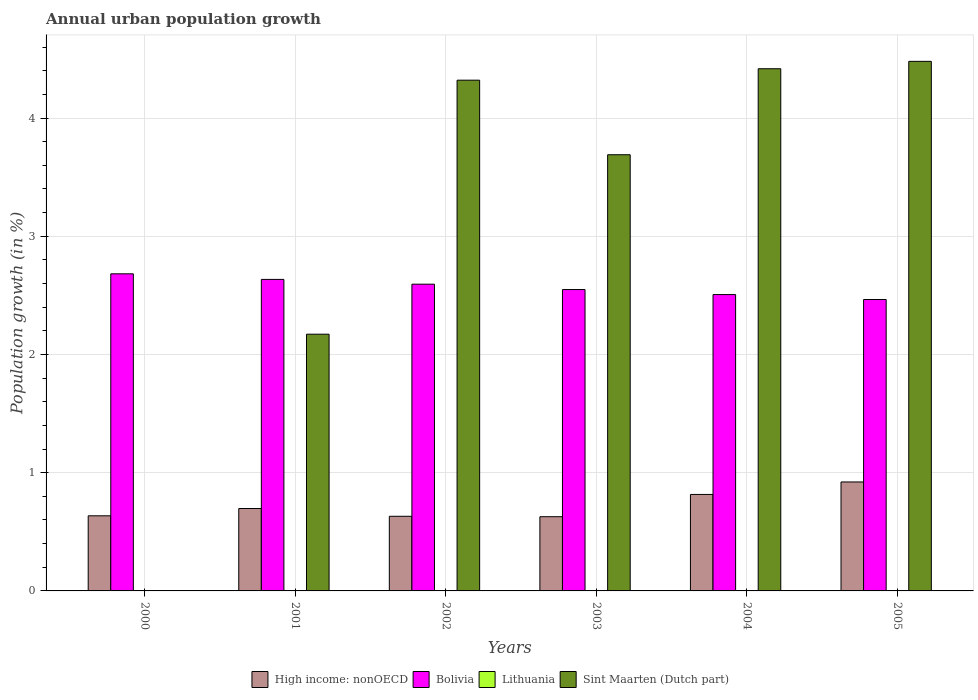How many groups of bars are there?
Provide a succinct answer. 6. How many bars are there on the 4th tick from the left?
Your response must be concise. 3. How many bars are there on the 6th tick from the right?
Your answer should be very brief. 2. In how many cases, is the number of bars for a given year not equal to the number of legend labels?
Offer a very short reply. 6. What is the percentage of urban population growth in Bolivia in 2000?
Make the answer very short. 2.68. Across all years, what is the maximum percentage of urban population growth in Sint Maarten (Dutch part)?
Offer a terse response. 4.48. Across all years, what is the minimum percentage of urban population growth in High income: nonOECD?
Provide a short and direct response. 0.63. What is the total percentage of urban population growth in Bolivia in the graph?
Offer a very short reply. 15.43. What is the difference between the percentage of urban population growth in Sint Maarten (Dutch part) in 2002 and that in 2005?
Make the answer very short. -0.16. What is the difference between the percentage of urban population growth in Sint Maarten (Dutch part) in 2000 and the percentage of urban population growth in High income: nonOECD in 2005?
Offer a very short reply. -0.92. What is the average percentage of urban population growth in Bolivia per year?
Provide a succinct answer. 2.57. In the year 2001, what is the difference between the percentage of urban population growth in High income: nonOECD and percentage of urban population growth in Sint Maarten (Dutch part)?
Provide a short and direct response. -1.47. What is the ratio of the percentage of urban population growth in Bolivia in 2003 to that in 2005?
Offer a very short reply. 1.03. Is the percentage of urban population growth in Bolivia in 2004 less than that in 2005?
Ensure brevity in your answer.  No. Is the difference between the percentage of urban population growth in High income: nonOECD in 2001 and 2005 greater than the difference between the percentage of urban population growth in Sint Maarten (Dutch part) in 2001 and 2005?
Offer a terse response. Yes. What is the difference between the highest and the second highest percentage of urban population growth in High income: nonOECD?
Offer a very short reply. 0.11. What is the difference between the highest and the lowest percentage of urban population growth in Sint Maarten (Dutch part)?
Offer a terse response. 4.48. In how many years, is the percentage of urban population growth in Bolivia greater than the average percentage of urban population growth in Bolivia taken over all years?
Provide a succinct answer. 3. Is the sum of the percentage of urban population growth in Sint Maarten (Dutch part) in 2003 and 2005 greater than the maximum percentage of urban population growth in Lithuania across all years?
Offer a terse response. Yes. Is it the case that in every year, the sum of the percentage of urban population growth in Bolivia and percentage of urban population growth in Lithuania is greater than the sum of percentage of urban population growth in Sint Maarten (Dutch part) and percentage of urban population growth in High income: nonOECD?
Provide a short and direct response. No. How many bars are there?
Make the answer very short. 17. Are all the bars in the graph horizontal?
Give a very brief answer. No. How many years are there in the graph?
Offer a terse response. 6. What is the difference between two consecutive major ticks on the Y-axis?
Make the answer very short. 1. Does the graph contain any zero values?
Make the answer very short. Yes. Where does the legend appear in the graph?
Your answer should be very brief. Bottom center. How are the legend labels stacked?
Provide a succinct answer. Horizontal. What is the title of the graph?
Provide a short and direct response. Annual urban population growth. What is the label or title of the X-axis?
Your answer should be compact. Years. What is the label or title of the Y-axis?
Your response must be concise. Population growth (in %). What is the Population growth (in %) of High income: nonOECD in 2000?
Your response must be concise. 0.64. What is the Population growth (in %) in Bolivia in 2000?
Your answer should be very brief. 2.68. What is the Population growth (in %) in Lithuania in 2000?
Your answer should be compact. 0. What is the Population growth (in %) of Sint Maarten (Dutch part) in 2000?
Your answer should be very brief. 0. What is the Population growth (in %) of High income: nonOECD in 2001?
Your answer should be very brief. 0.7. What is the Population growth (in %) in Bolivia in 2001?
Your response must be concise. 2.64. What is the Population growth (in %) of Lithuania in 2001?
Keep it short and to the point. 0. What is the Population growth (in %) of Sint Maarten (Dutch part) in 2001?
Provide a short and direct response. 2.17. What is the Population growth (in %) in High income: nonOECD in 2002?
Your answer should be very brief. 0.63. What is the Population growth (in %) of Bolivia in 2002?
Ensure brevity in your answer.  2.59. What is the Population growth (in %) of Lithuania in 2002?
Provide a short and direct response. 0. What is the Population growth (in %) of Sint Maarten (Dutch part) in 2002?
Make the answer very short. 4.32. What is the Population growth (in %) in High income: nonOECD in 2003?
Your answer should be very brief. 0.63. What is the Population growth (in %) in Bolivia in 2003?
Provide a short and direct response. 2.55. What is the Population growth (in %) of Lithuania in 2003?
Ensure brevity in your answer.  0. What is the Population growth (in %) in Sint Maarten (Dutch part) in 2003?
Your answer should be very brief. 3.69. What is the Population growth (in %) of High income: nonOECD in 2004?
Your response must be concise. 0.82. What is the Population growth (in %) in Bolivia in 2004?
Keep it short and to the point. 2.51. What is the Population growth (in %) in Sint Maarten (Dutch part) in 2004?
Provide a succinct answer. 4.42. What is the Population growth (in %) in High income: nonOECD in 2005?
Your response must be concise. 0.92. What is the Population growth (in %) in Bolivia in 2005?
Give a very brief answer. 2.47. What is the Population growth (in %) in Sint Maarten (Dutch part) in 2005?
Ensure brevity in your answer.  4.48. Across all years, what is the maximum Population growth (in %) of High income: nonOECD?
Keep it short and to the point. 0.92. Across all years, what is the maximum Population growth (in %) in Bolivia?
Provide a succinct answer. 2.68. Across all years, what is the maximum Population growth (in %) of Sint Maarten (Dutch part)?
Provide a short and direct response. 4.48. Across all years, what is the minimum Population growth (in %) in High income: nonOECD?
Offer a very short reply. 0.63. Across all years, what is the minimum Population growth (in %) in Bolivia?
Your response must be concise. 2.47. What is the total Population growth (in %) in High income: nonOECD in the graph?
Provide a succinct answer. 4.33. What is the total Population growth (in %) of Bolivia in the graph?
Keep it short and to the point. 15.43. What is the total Population growth (in %) of Sint Maarten (Dutch part) in the graph?
Offer a terse response. 19.08. What is the difference between the Population growth (in %) in High income: nonOECD in 2000 and that in 2001?
Your answer should be compact. -0.06. What is the difference between the Population growth (in %) of Bolivia in 2000 and that in 2001?
Provide a succinct answer. 0.05. What is the difference between the Population growth (in %) of High income: nonOECD in 2000 and that in 2002?
Make the answer very short. 0. What is the difference between the Population growth (in %) of Bolivia in 2000 and that in 2002?
Your answer should be very brief. 0.09. What is the difference between the Population growth (in %) of High income: nonOECD in 2000 and that in 2003?
Ensure brevity in your answer.  0.01. What is the difference between the Population growth (in %) in Bolivia in 2000 and that in 2003?
Keep it short and to the point. 0.13. What is the difference between the Population growth (in %) of High income: nonOECD in 2000 and that in 2004?
Make the answer very short. -0.18. What is the difference between the Population growth (in %) in Bolivia in 2000 and that in 2004?
Provide a succinct answer. 0.18. What is the difference between the Population growth (in %) of High income: nonOECD in 2000 and that in 2005?
Make the answer very short. -0.29. What is the difference between the Population growth (in %) of Bolivia in 2000 and that in 2005?
Provide a succinct answer. 0.22. What is the difference between the Population growth (in %) in High income: nonOECD in 2001 and that in 2002?
Offer a very short reply. 0.07. What is the difference between the Population growth (in %) in Bolivia in 2001 and that in 2002?
Give a very brief answer. 0.04. What is the difference between the Population growth (in %) in Sint Maarten (Dutch part) in 2001 and that in 2002?
Offer a very short reply. -2.15. What is the difference between the Population growth (in %) in High income: nonOECD in 2001 and that in 2003?
Provide a succinct answer. 0.07. What is the difference between the Population growth (in %) of Bolivia in 2001 and that in 2003?
Provide a short and direct response. 0.09. What is the difference between the Population growth (in %) of Sint Maarten (Dutch part) in 2001 and that in 2003?
Keep it short and to the point. -1.52. What is the difference between the Population growth (in %) in High income: nonOECD in 2001 and that in 2004?
Provide a short and direct response. -0.12. What is the difference between the Population growth (in %) in Bolivia in 2001 and that in 2004?
Keep it short and to the point. 0.13. What is the difference between the Population growth (in %) of Sint Maarten (Dutch part) in 2001 and that in 2004?
Offer a terse response. -2.25. What is the difference between the Population growth (in %) in High income: nonOECD in 2001 and that in 2005?
Make the answer very short. -0.22. What is the difference between the Population growth (in %) in Bolivia in 2001 and that in 2005?
Your answer should be compact. 0.17. What is the difference between the Population growth (in %) in Sint Maarten (Dutch part) in 2001 and that in 2005?
Offer a terse response. -2.31. What is the difference between the Population growth (in %) in High income: nonOECD in 2002 and that in 2003?
Keep it short and to the point. 0. What is the difference between the Population growth (in %) of Bolivia in 2002 and that in 2003?
Give a very brief answer. 0.05. What is the difference between the Population growth (in %) of Sint Maarten (Dutch part) in 2002 and that in 2003?
Ensure brevity in your answer.  0.63. What is the difference between the Population growth (in %) of High income: nonOECD in 2002 and that in 2004?
Your answer should be very brief. -0.18. What is the difference between the Population growth (in %) of Bolivia in 2002 and that in 2004?
Provide a short and direct response. 0.09. What is the difference between the Population growth (in %) in Sint Maarten (Dutch part) in 2002 and that in 2004?
Provide a short and direct response. -0.1. What is the difference between the Population growth (in %) in High income: nonOECD in 2002 and that in 2005?
Provide a short and direct response. -0.29. What is the difference between the Population growth (in %) of Bolivia in 2002 and that in 2005?
Provide a succinct answer. 0.13. What is the difference between the Population growth (in %) in Sint Maarten (Dutch part) in 2002 and that in 2005?
Your response must be concise. -0.16. What is the difference between the Population growth (in %) in High income: nonOECD in 2003 and that in 2004?
Your answer should be very brief. -0.19. What is the difference between the Population growth (in %) in Bolivia in 2003 and that in 2004?
Your response must be concise. 0.04. What is the difference between the Population growth (in %) in Sint Maarten (Dutch part) in 2003 and that in 2004?
Provide a succinct answer. -0.73. What is the difference between the Population growth (in %) in High income: nonOECD in 2003 and that in 2005?
Ensure brevity in your answer.  -0.29. What is the difference between the Population growth (in %) of Bolivia in 2003 and that in 2005?
Make the answer very short. 0.08. What is the difference between the Population growth (in %) in Sint Maarten (Dutch part) in 2003 and that in 2005?
Offer a very short reply. -0.79. What is the difference between the Population growth (in %) in High income: nonOECD in 2004 and that in 2005?
Your answer should be compact. -0.11. What is the difference between the Population growth (in %) in Bolivia in 2004 and that in 2005?
Your response must be concise. 0.04. What is the difference between the Population growth (in %) in Sint Maarten (Dutch part) in 2004 and that in 2005?
Your answer should be compact. -0.06. What is the difference between the Population growth (in %) of High income: nonOECD in 2000 and the Population growth (in %) of Bolivia in 2001?
Provide a succinct answer. -2. What is the difference between the Population growth (in %) in High income: nonOECD in 2000 and the Population growth (in %) in Sint Maarten (Dutch part) in 2001?
Give a very brief answer. -1.54. What is the difference between the Population growth (in %) in Bolivia in 2000 and the Population growth (in %) in Sint Maarten (Dutch part) in 2001?
Your answer should be compact. 0.51. What is the difference between the Population growth (in %) in High income: nonOECD in 2000 and the Population growth (in %) in Bolivia in 2002?
Keep it short and to the point. -1.96. What is the difference between the Population growth (in %) of High income: nonOECD in 2000 and the Population growth (in %) of Sint Maarten (Dutch part) in 2002?
Your response must be concise. -3.68. What is the difference between the Population growth (in %) of Bolivia in 2000 and the Population growth (in %) of Sint Maarten (Dutch part) in 2002?
Give a very brief answer. -1.64. What is the difference between the Population growth (in %) of High income: nonOECD in 2000 and the Population growth (in %) of Bolivia in 2003?
Your answer should be compact. -1.91. What is the difference between the Population growth (in %) in High income: nonOECD in 2000 and the Population growth (in %) in Sint Maarten (Dutch part) in 2003?
Keep it short and to the point. -3.05. What is the difference between the Population growth (in %) of Bolivia in 2000 and the Population growth (in %) of Sint Maarten (Dutch part) in 2003?
Provide a succinct answer. -1.01. What is the difference between the Population growth (in %) in High income: nonOECD in 2000 and the Population growth (in %) in Bolivia in 2004?
Give a very brief answer. -1.87. What is the difference between the Population growth (in %) of High income: nonOECD in 2000 and the Population growth (in %) of Sint Maarten (Dutch part) in 2004?
Ensure brevity in your answer.  -3.78. What is the difference between the Population growth (in %) in Bolivia in 2000 and the Population growth (in %) in Sint Maarten (Dutch part) in 2004?
Your response must be concise. -1.73. What is the difference between the Population growth (in %) in High income: nonOECD in 2000 and the Population growth (in %) in Bolivia in 2005?
Provide a succinct answer. -1.83. What is the difference between the Population growth (in %) in High income: nonOECD in 2000 and the Population growth (in %) in Sint Maarten (Dutch part) in 2005?
Ensure brevity in your answer.  -3.84. What is the difference between the Population growth (in %) in Bolivia in 2000 and the Population growth (in %) in Sint Maarten (Dutch part) in 2005?
Your answer should be compact. -1.8. What is the difference between the Population growth (in %) of High income: nonOECD in 2001 and the Population growth (in %) of Bolivia in 2002?
Offer a terse response. -1.9. What is the difference between the Population growth (in %) in High income: nonOECD in 2001 and the Population growth (in %) in Sint Maarten (Dutch part) in 2002?
Keep it short and to the point. -3.62. What is the difference between the Population growth (in %) in Bolivia in 2001 and the Population growth (in %) in Sint Maarten (Dutch part) in 2002?
Provide a short and direct response. -1.69. What is the difference between the Population growth (in %) of High income: nonOECD in 2001 and the Population growth (in %) of Bolivia in 2003?
Provide a succinct answer. -1.85. What is the difference between the Population growth (in %) in High income: nonOECD in 2001 and the Population growth (in %) in Sint Maarten (Dutch part) in 2003?
Your answer should be very brief. -2.99. What is the difference between the Population growth (in %) of Bolivia in 2001 and the Population growth (in %) of Sint Maarten (Dutch part) in 2003?
Offer a very short reply. -1.05. What is the difference between the Population growth (in %) in High income: nonOECD in 2001 and the Population growth (in %) in Bolivia in 2004?
Keep it short and to the point. -1.81. What is the difference between the Population growth (in %) of High income: nonOECD in 2001 and the Population growth (in %) of Sint Maarten (Dutch part) in 2004?
Provide a succinct answer. -3.72. What is the difference between the Population growth (in %) in Bolivia in 2001 and the Population growth (in %) in Sint Maarten (Dutch part) in 2004?
Offer a terse response. -1.78. What is the difference between the Population growth (in %) in High income: nonOECD in 2001 and the Population growth (in %) in Bolivia in 2005?
Your answer should be compact. -1.77. What is the difference between the Population growth (in %) of High income: nonOECD in 2001 and the Population growth (in %) of Sint Maarten (Dutch part) in 2005?
Offer a terse response. -3.78. What is the difference between the Population growth (in %) of Bolivia in 2001 and the Population growth (in %) of Sint Maarten (Dutch part) in 2005?
Keep it short and to the point. -1.84. What is the difference between the Population growth (in %) in High income: nonOECD in 2002 and the Population growth (in %) in Bolivia in 2003?
Your response must be concise. -1.92. What is the difference between the Population growth (in %) of High income: nonOECD in 2002 and the Population growth (in %) of Sint Maarten (Dutch part) in 2003?
Ensure brevity in your answer.  -3.06. What is the difference between the Population growth (in %) in Bolivia in 2002 and the Population growth (in %) in Sint Maarten (Dutch part) in 2003?
Provide a succinct answer. -1.09. What is the difference between the Population growth (in %) of High income: nonOECD in 2002 and the Population growth (in %) of Bolivia in 2004?
Your answer should be compact. -1.88. What is the difference between the Population growth (in %) in High income: nonOECD in 2002 and the Population growth (in %) in Sint Maarten (Dutch part) in 2004?
Offer a very short reply. -3.79. What is the difference between the Population growth (in %) in Bolivia in 2002 and the Population growth (in %) in Sint Maarten (Dutch part) in 2004?
Provide a short and direct response. -1.82. What is the difference between the Population growth (in %) of High income: nonOECD in 2002 and the Population growth (in %) of Bolivia in 2005?
Make the answer very short. -1.83. What is the difference between the Population growth (in %) of High income: nonOECD in 2002 and the Population growth (in %) of Sint Maarten (Dutch part) in 2005?
Provide a succinct answer. -3.85. What is the difference between the Population growth (in %) in Bolivia in 2002 and the Population growth (in %) in Sint Maarten (Dutch part) in 2005?
Your answer should be compact. -1.88. What is the difference between the Population growth (in %) of High income: nonOECD in 2003 and the Population growth (in %) of Bolivia in 2004?
Keep it short and to the point. -1.88. What is the difference between the Population growth (in %) in High income: nonOECD in 2003 and the Population growth (in %) in Sint Maarten (Dutch part) in 2004?
Give a very brief answer. -3.79. What is the difference between the Population growth (in %) in Bolivia in 2003 and the Population growth (in %) in Sint Maarten (Dutch part) in 2004?
Your answer should be very brief. -1.87. What is the difference between the Population growth (in %) in High income: nonOECD in 2003 and the Population growth (in %) in Bolivia in 2005?
Your answer should be compact. -1.84. What is the difference between the Population growth (in %) of High income: nonOECD in 2003 and the Population growth (in %) of Sint Maarten (Dutch part) in 2005?
Offer a very short reply. -3.85. What is the difference between the Population growth (in %) in Bolivia in 2003 and the Population growth (in %) in Sint Maarten (Dutch part) in 2005?
Provide a short and direct response. -1.93. What is the difference between the Population growth (in %) of High income: nonOECD in 2004 and the Population growth (in %) of Bolivia in 2005?
Offer a terse response. -1.65. What is the difference between the Population growth (in %) in High income: nonOECD in 2004 and the Population growth (in %) in Sint Maarten (Dutch part) in 2005?
Offer a terse response. -3.66. What is the difference between the Population growth (in %) in Bolivia in 2004 and the Population growth (in %) in Sint Maarten (Dutch part) in 2005?
Make the answer very short. -1.97. What is the average Population growth (in %) of High income: nonOECD per year?
Give a very brief answer. 0.72. What is the average Population growth (in %) in Bolivia per year?
Your response must be concise. 2.57. What is the average Population growth (in %) in Sint Maarten (Dutch part) per year?
Give a very brief answer. 3.18. In the year 2000, what is the difference between the Population growth (in %) in High income: nonOECD and Population growth (in %) in Bolivia?
Offer a terse response. -2.05. In the year 2001, what is the difference between the Population growth (in %) in High income: nonOECD and Population growth (in %) in Bolivia?
Offer a terse response. -1.94. In the year 2001, what is the difference between the Population growth (in %) in High income: nonOECD and Population growth (in %) in Sint Maarten (Dutch part)?
Make the answer very short. -1.47. In the year 2001, what is the difference between the Population growth (in %) in Bolivia and Population growth (in %) in Sint Maarten (Dutch part)?
Make the answer very short. 0.46. In the year 2002, what is the difference between the Population growth (in %) in High income: nonOECD and Population growth (in %) in Bolivia?
Provide a short and direct response. -1.96. In the year 2002, what is the difference between the Population growth (in %) in High income: nonOECD and Population growth (in %) in Sint Maarten (Dutch part)?
Your answer should be very brief. -3.69. In the year 2002, what is the difference between the Population growth (in %) of Bolivia and Population growth (in %) of Sint Maarten (Dutch part)?
Offer a terse response. -1.73. In the year 2003, what is the difference between the Population growth (in %) of High income: nonOECD and Population growth (in %) of Bolivia?
Provide a short and direct response. -1.92. In the year 2003, what is the difference between the Population growth (in %) of High income: nonOECD and Population growth (in %) of Sint Maarten (Dutch part)?
Give a very brief answer. -3.06. In the year 2003, what is the difference between the Population growth (in %) in Bolivia and Population growth (in %) in Sint Maarten (Dutch part)?
Make the answer very short. -1.14. In the year 2004, what is the difference between the Population growth (in %) of High income: nonOECD and Population growth (in %) of Bolivia?
Provide a short and direct response. -1.69. In the year 2004, what is the difference between the Population growth (in %) in High income: nonOECD and Population growth (in %) in Sint Maarten (Dutch part)?
Make the answer very short. -3.6. In the year 2004, what is the difference between the Population growth (in %) of Bolivia and Population growth (in %) of Sint Maarten (Dutch part)?
Your answer should be compact. -1.91. In the year 2005, what is the difference between the Population growth (in %) in High income: nonOECD and Population growth (in %) in Bolivia?
Provide a short and direct response. -1.54. In the year 2005, what is the difference between the Population growth (in %) of High income: nonOECD and Population growth (in %) of Sint Maarten (Dutch part)?
Ensure brevity in your answer.  -3.56. In the year 2005, what is the difference between the Population growth (in %) in Bolivia and Population growth (in %) in Sint Maarten (Dutch part)?
Provide a short and direct response. -2.01. What is the ratio of the Population growth (in %) in High income: nonOECD in 2000 to that in 2001?
Make the answer very short. 0.91. What is the ratio of the Population growth (in %) in Bolivia in 2000 to that in 2001?
Provide a short and direct response. 1.02. What is the ratio of the Population growth (in %) in High income: nonOECD in 2000 to that in 2002?
Make the answer very short. 1.01. What is the ratio of the Population growth (in %) of Bolivia in 2000 to that in 2002?
Provide a succinct answer. 1.03. What is the ratio of the Population growth (in %) of High income: nonOECD in 2000 to that in 2003?
Offer a very short reply. 1.01. What is the ratio of the Population growth (in %) of Bolivia in 2000 to that in 2003?
Provide a short and direct response. 1.05. What is the ratio of the Population growth (in %) of High income: nonOECD in 2000 to that in 2004?
Make the answer very short. 0.78. What is the ratio of the Population growth (in %) in Bolivia in 2000 to that in 2004?
Offer a very short reply. 1.07. What is the ratio of the Population growth (in %) of High income: nonOECD in 2000 to that in 2005?
Make the answer very short. 0.69. What is the ratio of the Population growth (in %) of Bolivia in 2000 to that in 2005?
Your response must be concise. 1.09. What is the ratio of the Population growth (in %) in High income: nonOECD in 2001 to that in 2002?
Give a very brief answer. 1.1. What is the ratio of the Population growth (in %) in Bolivia in 2001 to that in 2002?
Your answer should be very brief. 1.02. What is the ratio of the Population growth (in %) in Sint Maarten (Dutch part) in 2001 to that in 2002?
Your response must be concise. 0.5. What is the ratio of the Population growth (in %) of High income: nonOECD in 2001 to that in 2003?
Your answer should be compact. 1.11. What is the ratio of the Population growth (in %) of Bolivia in 2001 to that in 2003?
Offer a terse response. 1.03. What is the ratio of the Population growth (in %) of Sint Maarten (Dutch part) in 2001 to that in 2003?
Make the answer very short. 0.59. What is the ratio of the Population growth (in %) in High income: nonOECD in 2001 to that in 2004?
Offer a terse response. 0.85. What is the ratio of the Population growth (in %) of Bolivia in 2001 to that in 2004?
Offer a terse response. 1.05. What is the ratio of the Population growth (in %) in Sint Maarten (Dutch part) in 2001 to that in 2004?
Your answer should be very brief. 0.49. What is the ratio of the Population growth (in %) in High income: nonOECD in 2001 to that in 2005?
Provide a succinct answer. 0.76. What is the ratio of the Population growth (in %) of Bolivia in 2001 to that in 2005?
Make the answer very short. 1.07. What is the ratio of the Population growth (in %) of Sint Maarten (Dutch part) in 2001 to that in 2005?
Ensure brevity in your answer.  0.48. What is the ratio of the Population growth (in %) of High income: nonOECD in 2002 to that in 2003?
Your answer should be compact. 1.01. What is the ratio of the Population growth (in %) in Bolivia in 2002 to that in 2003?
Keep it short and to the point. 1.02. What is the ratio of the Population growth (in %) of Sint Maarten (Dutch part) in 2002 to that in 2003?
Provide a succinct answer. 1.17. What is the ratio of the Population growth (in %) in High income: nonOECD in 2002 to that in 2004?
Make the answer very short. 0.77. What is the ratio of the Population growth (in %) of Bolivia in 2002 to that in 2004?
Offer a terse response. 1.03. What is the ratio of the Population growth (in %) of Sint Maarten (Dutch part) in 2002 to that in 2004?
Offer a very short reply. 0.98. What is the ratio of the Population growth (in %) in High income: nonOECD in 2002 to that in 2005?
Offer a very short reply. 0.68. What is the ratio of the Population growth (in %) in Bolivia in 2002 to that in 2005?
Offer a terse response. 1.05. What is the ratio of the Population growth (in %) in Sint Maarten (Dutch part) in 2002 to that in 2005?
Your answer should be compact. 0.96. What is the ratio of the Population growth (in %) of High income: nonOECD in 2003 to that in 2004?
Ensure brevity in your answer.  0.77. What is the ratio of the Population growth (in %) in Sint Maarten (Dutch part) in 2003 to that in 2004?
Your response must be concise. 0.84. What is the ratio of the Population growth (in %) in High income: nonOECD in 2003 to that in 2005?
Offer a very short reply. 0.68. What is the ratio of the Population growth (in %) in Bolivia in 2003 to that in 2005?
Offer a terse response. 1.03. What is the ratio of the Population growth (in %) in Sint Maarten (Dutch part) in 2003 to that in 2005?
Keep it short and to the point. 0.82. What is the ratio of the Population growth (in %) in High income: nonOECD in 2004 to that in 2005?
Provide a short and direct response. 0.89. What is the ratio of the Population growth (in %) in Bolivia in 2004 to that in 2005?
Ensure brevity in your answer.  1.02. What is the difference between the highest and the second highest Population growth (in %) of High income: nonOECD?
Provide a short and direct response. 0.11. What is the difference between the highest and the second highest Population growth (in %) in Bolivia?
Your response must be concise. 0.05. What is the difference between the highest and the second highest Population growth (in %) of Sint Maarten (Dutch part)?
Ensure brevity in your answer.  0.06. What is the difference between the highest and the lowest Population growth (in %) in High income: nonOECD?
Give a very brief answer. 0.29. What is the difference between the highest and the lowest Population growth (in %) of Bolivia?
Make the answer very short. 0.22. What is the difference between the highest and the lowest Population growth (in %) in Sint Maarten (Dutch part)?
Offer a terse response. 4.48. 